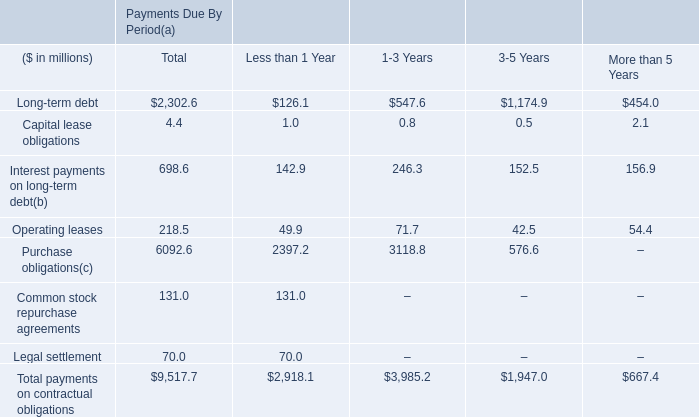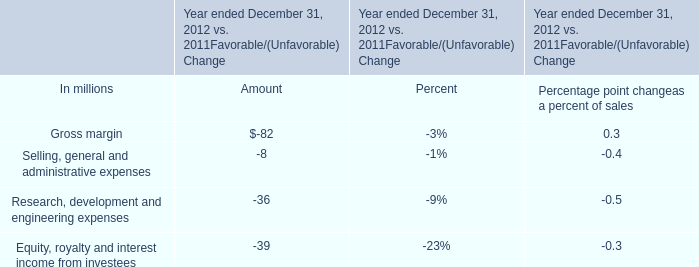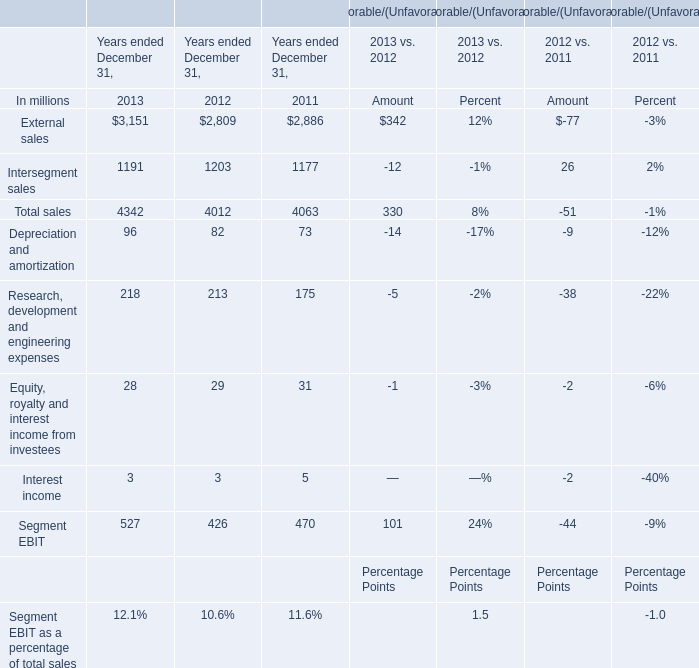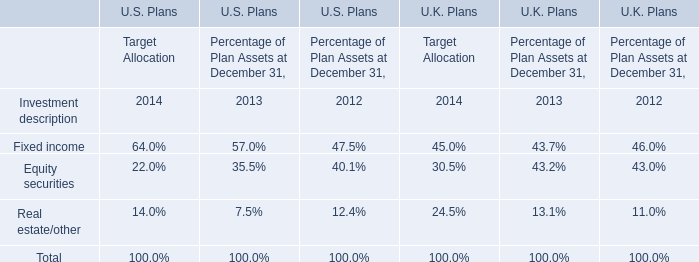payments to participants in the unfunded german plans are expected to be total approximately how much , in millions , for the years 2008 through 2012? 
Computations: ((2012 - 2008) * 26)
Answer: 104.0. 